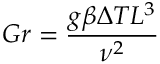Convert formula to latex. <formula><loc_0><loc_0><loc_500><loc_500>G r = { \frac { g \beta \Delta T L ^ { 3 } } { \nu ^ { 2 } } }</formula> 